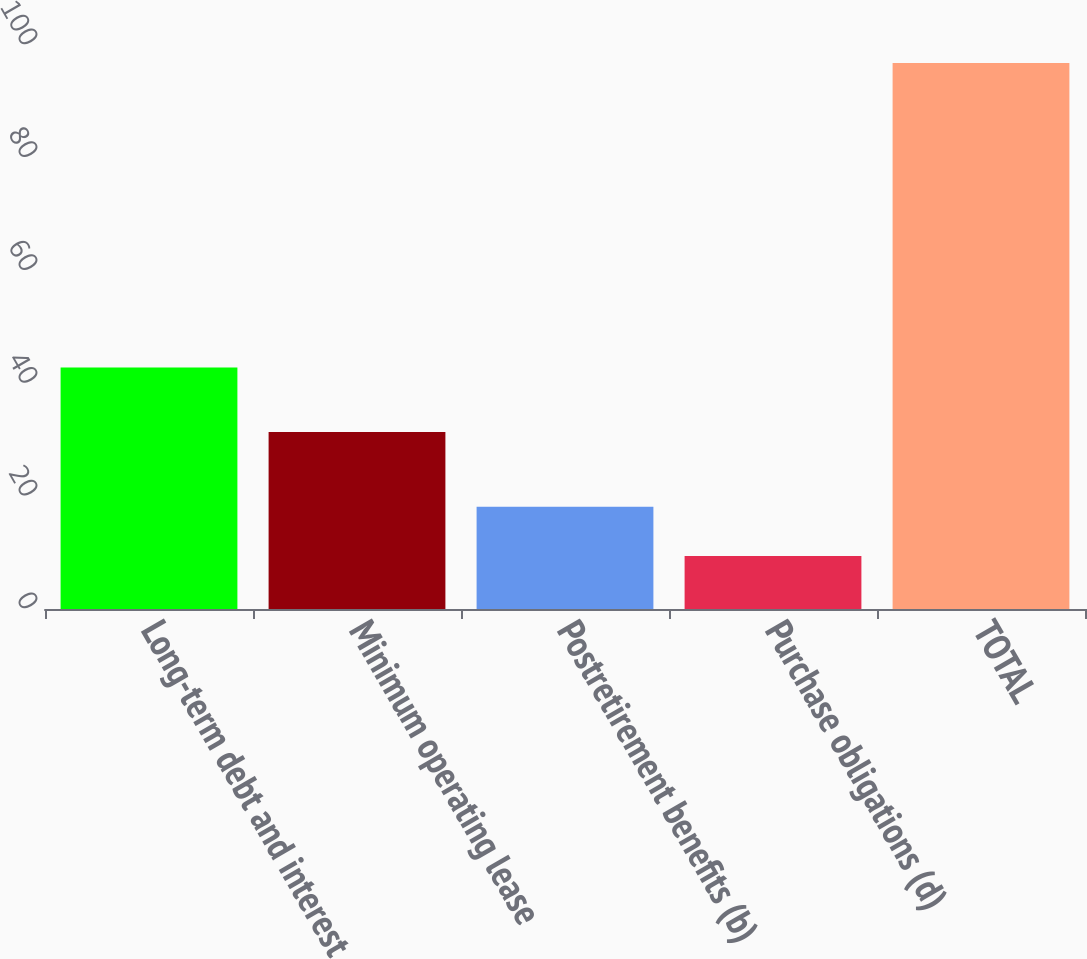<chart> <loc_0><loc_0><loc_500><loc_500><bar_chart><fcel>Long-term debt and interest<fcel>Minimum operating lease<fcel>Postretirement benefits (b)<fcel>Purchase obligations (d)<fcel>TOTAL<nl><fcel>42.8<fcel>31.4<fcel>18.14<fcel>9.4<fcel>96.8<nl></chart> 